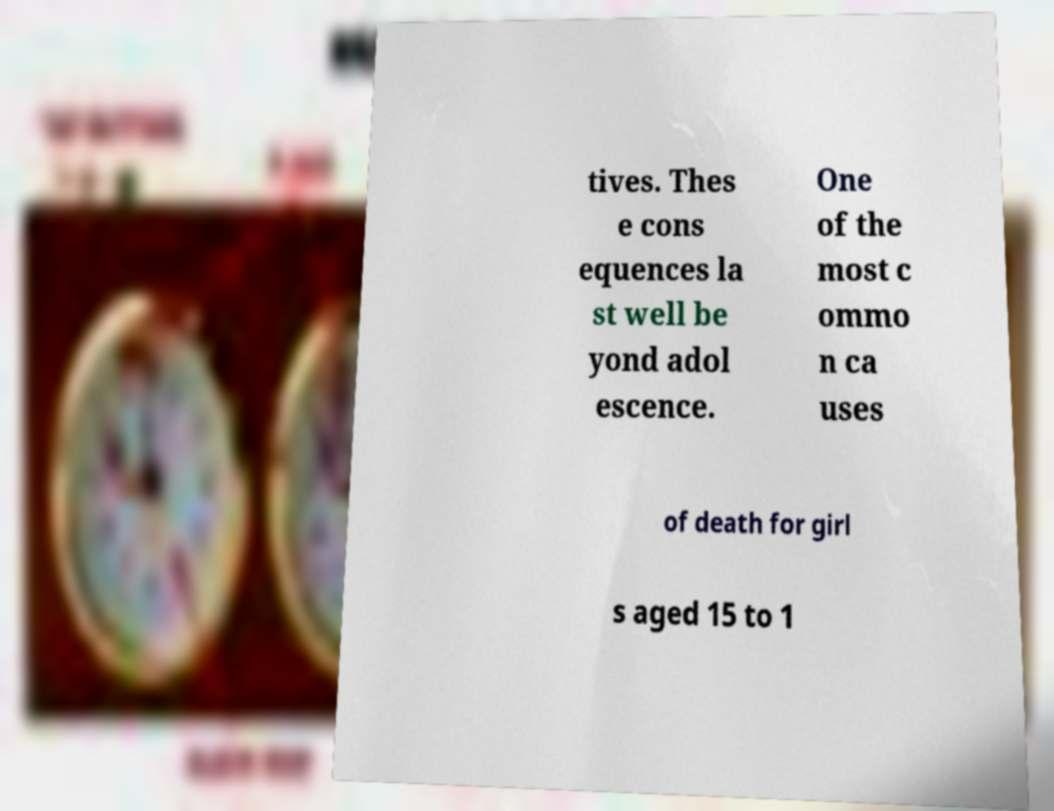Please read and relay the text visible in this image. What does it say? tives. Thes e cons equences la st well be yond adol escence. One of the most c ommo n ca uses of death for girl s aged 15 to 1 